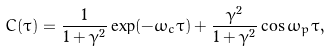Convert formula to latex. <formula><loc_0><loc_0><loc_500><loc_500>C ( \tau ) = \frac { 1 } { 1 + \gamma ^ { 2 } } \exp ( - \omega _ { c } \tau ) + \frac { \gamma ^ { 2 } } { 1 + \gamma ^ { 2 } } \cos \omega _ { p } \tau ,</formula> 